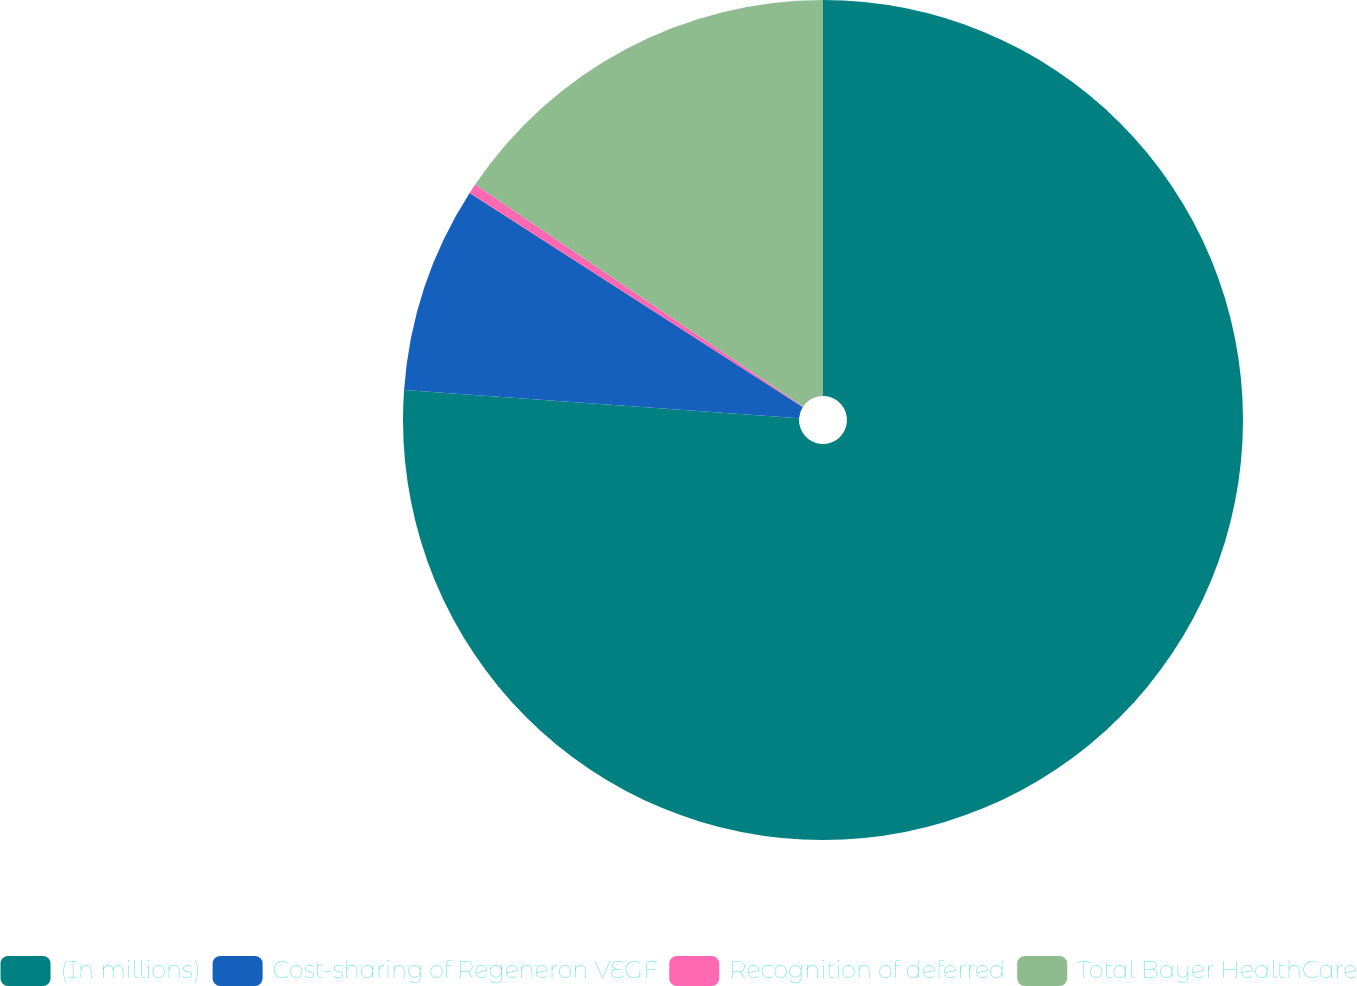<chart> <loc_0><loc_0><loc_500><loc_500><pie_chart><fcel>(In millions)<fcel>Cost-sharing of Regeneron VEGF<fcel>Recognition of deferred<fcel>Total Bayer HealthCare<nl><fcel>76.14%<fcel>7.95%<fcel>0.38%<fcel>15.53%<nl></chart> 